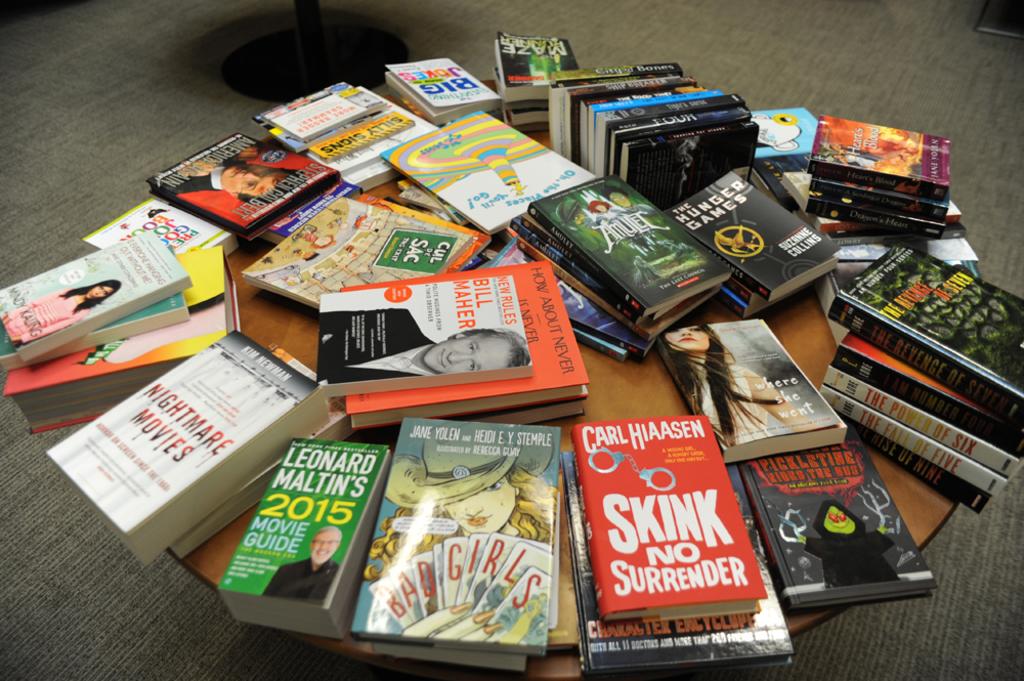Who wrote skink no surrender?
Give a very brief answer. Carl hiaasen. What year is the movie guide for?
Offer a very short reply. 2015. 